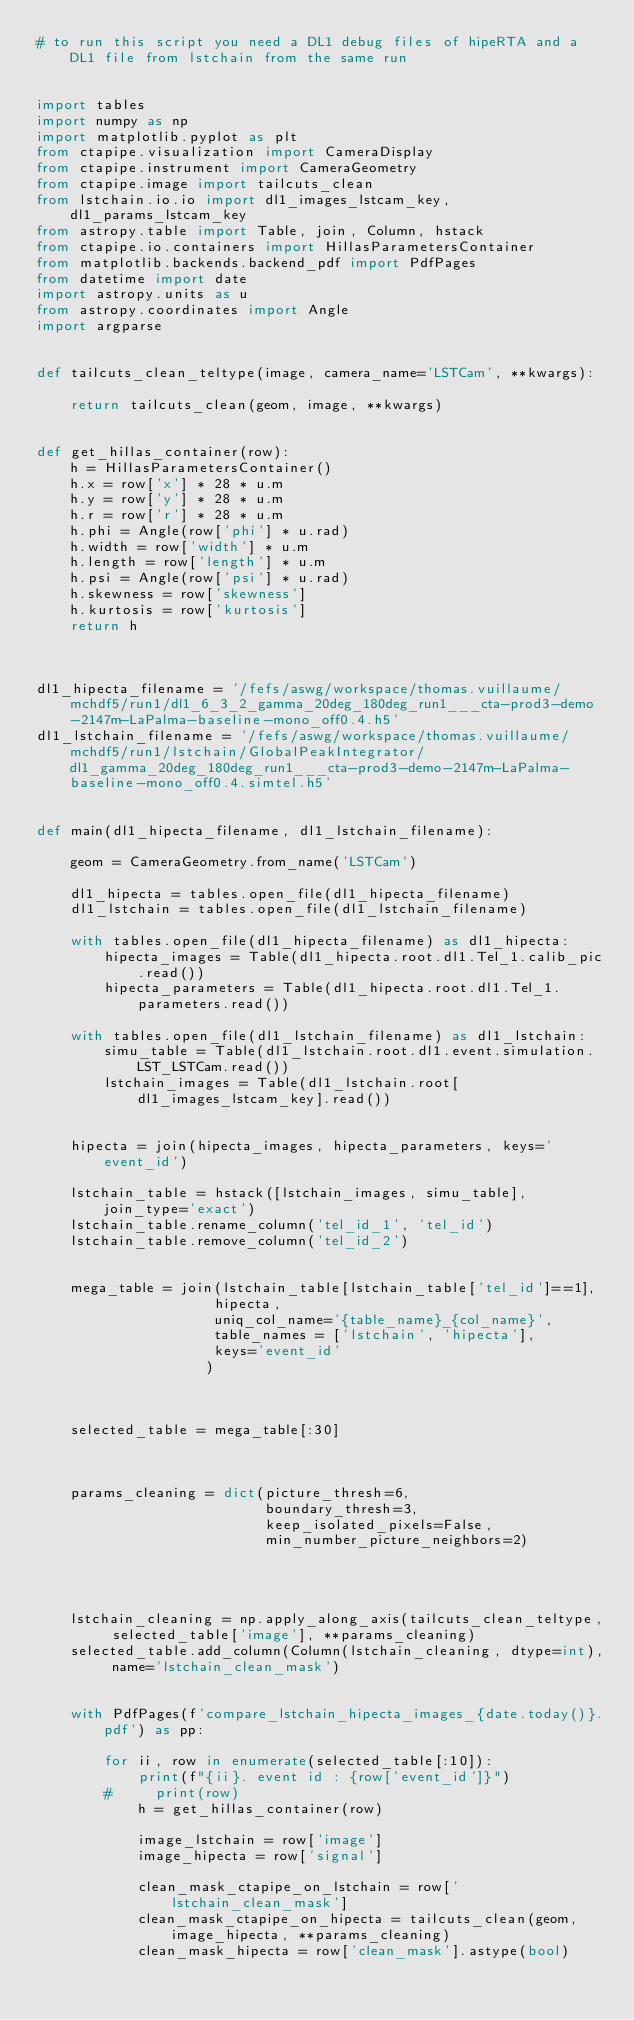<code> <loc_0><loc_0><loc_500><loc_500><_Python_># to run this script you need a DL1 debug files of hipeRTA and a DL1 file from lstchain from the same run


import tables
import numpy as np
import matplotlib.pyplot as plt
from ctapipe.visualization import CameraDisplay
from ctapipe.instrument import CameraGeometry
from ctapipe.image import tailcuts_clean
from lstchain.io.io import dl1_images_lstcam_key, dl1_params_lstcam_key
from astropy.table import Table, join, Column, hstack
from ctapipe.io.containers import HillasParametersContainer
from matplotlib.backends.backend_pdf import PdfPages
from datetime import date
import astropy.units as u
from astropy.coordinates import Angle
import argparse


def tailcuts_clean_teltype(image, camera_name='LSTCam', **kwargs):

    return tailcuts_clean(geom, image, **kwargs)


def get_hillas_container(row):
    h = HillasParametersContainer()
    h.x = row['x'] * 28 * u.m
    h.y = row['y'] * 28 * u.m
    h.r = row['r'] * 28 * u.m
    h.phi = Angle(row['phi'] * u.rad)
    h.width = row['width'] * u.m
    h.length = row['length'] * u.m
    h.psi = Angle(row['psi'] * u.rad)
    h.skewness = row['skewness']
    h.kurtosis = row['kurtosis']
    return h



dl1_hipecta_filename = '/fefs/aswg/workspace/thomas.vuillaume/mchdf5/run1/dl1_6_3_2_gamma_20deg_180deg_run1___cta-prod3-demo-2147m-LaPalma-baseline-mono_off0.4.h5'
dl1_lstchain_filename = '/fefs/aswg/workspace/thomas.vuillaume/mchdf5/run1/lstchain/GlobalPeakIntegrator/dl1_gamma_20deg_180deg_run1___cta-prod3-demo-2147m-LaPalma-baseline-mono_off0.4.simtel.h5'


def main(dl1_hipecta_filename, dl1_lstchain_filename):

    geom = CameraGeometry.from_name('LSTCam')

    dl1_hipecta = tables.open_file(dl1_hipecta_filename)
    dl1_lstchain = tables.open_file(dl1_lstchain_filename)

    with tables.open_file(dl1_hipecta_filename) as dl1_hipecta:
        hipecta_images = Table(dl1_hipecta.root.dl1.Tel_1.calib_pic.read())
        hipecta_parameters = Table(dl1_hipecta.root.dl1.Tel_1.parameters.read())

    with tables.open_file(dl1_lstchain_filename) as dl1_lstchain:
        simu_table = Table(dl1_lstchain.root.dl1.event.simulation.LST_LSTCam.read())
        lstchain_images = Table(dl1_lstchain.root[dl1_images_lstcam_key].read())


    hipecta = join(hipecta_images, hipecta_parameters, keys='event_id')

    lstchain_table = hstack([lstchain_images, simu_table], join_type='exact')
    lstchain_table.rename_column('tel_id_1', 'tel_id')
    lstchain_table.remove_column('tel_id_2')


    mega_table = join(lstchain_table[lstchain_table['tel_id']==1],
                     hipecta, 
                     uniq_col_name='{table_name}_{col_name}',
                     table_names = ['lstchain', 'hipecta'],
                     keys='event_id'
                    )



    selected_table = mega_table[:30]



    params_cleaning = dict(picture_thresh=6,
                           boundary_thresh=3,
                           keep_isolated_pixels=False,
                           min_number_picture_neighbors=2)




    lstchain_cleaning = np.apply_along_axis(tailcuts_clean_teltype, selected_table['image'], **params_cleaning)
    selected_table.add_column(Column(lstchain_cleaning, dtype=int), name='lstchain_clean_mask')


    with PdfPages(f'compare_lstchain_hipecta_images_{date.today()}.pdf') as pp:

        for ii, row in enumerate(selected_table[:10]):
            print(f"{ii}. event id : {row['event_id']}")
        #     print(row)
            h = get_hillas_container(row)

            image_lstchain = row['image']
            image_hipecta = row['signal']

            clean_mask_ctapipe_on_lstchain = row['lstchain_clean_mask']
            clean_mask_ctapipe_on_hipecta = tailcuts_clean(geom, image_hipecta, **params_cleaning)
            clean_mask_hipecta = row['clean_mask'].astype(bool)
</code> 